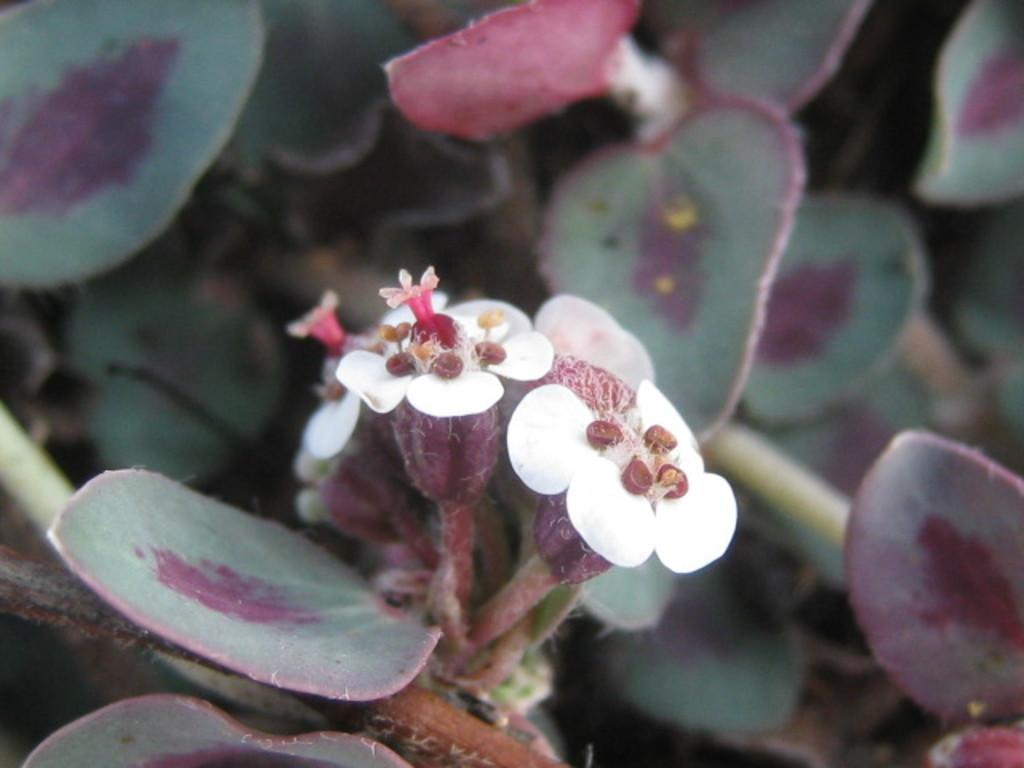What is the main subject of the image? There is a flower in the middle of the image. Can you describe the colors of the flower? The flower has white and pink colors. What else can be seen in the background of the image? There are leaves in the background of the image. What time is displayed on the calendar in the image? There is no calendar present in the image, so it is not possible to determine the time displayed. 